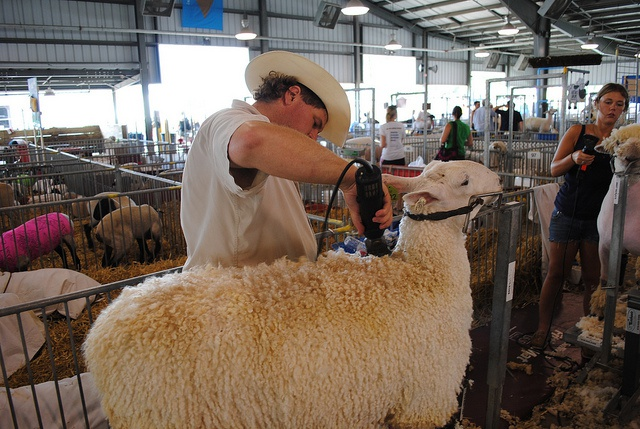Describe the objects in this image and their specific colors. I can see sheep in purple, gray, tan, olive, and darkgray tones, people in purple, gray, darkgray, and brown tones, people in purple, black, maroon, and gray tones, sheep in purple, gray, darkgray, and black tones, and sheep in purple and gray tones in this image. 